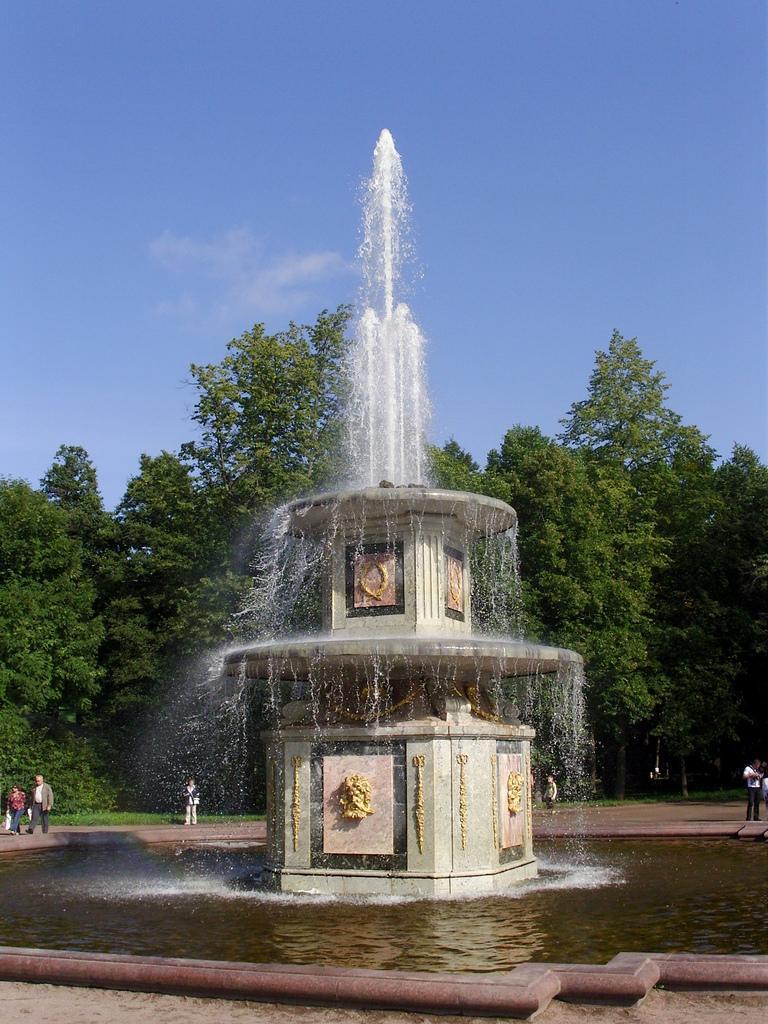Can you describe this image briefly? In this image we can see there is a water fountain. There are people and trees. In the background we can see the sky. 